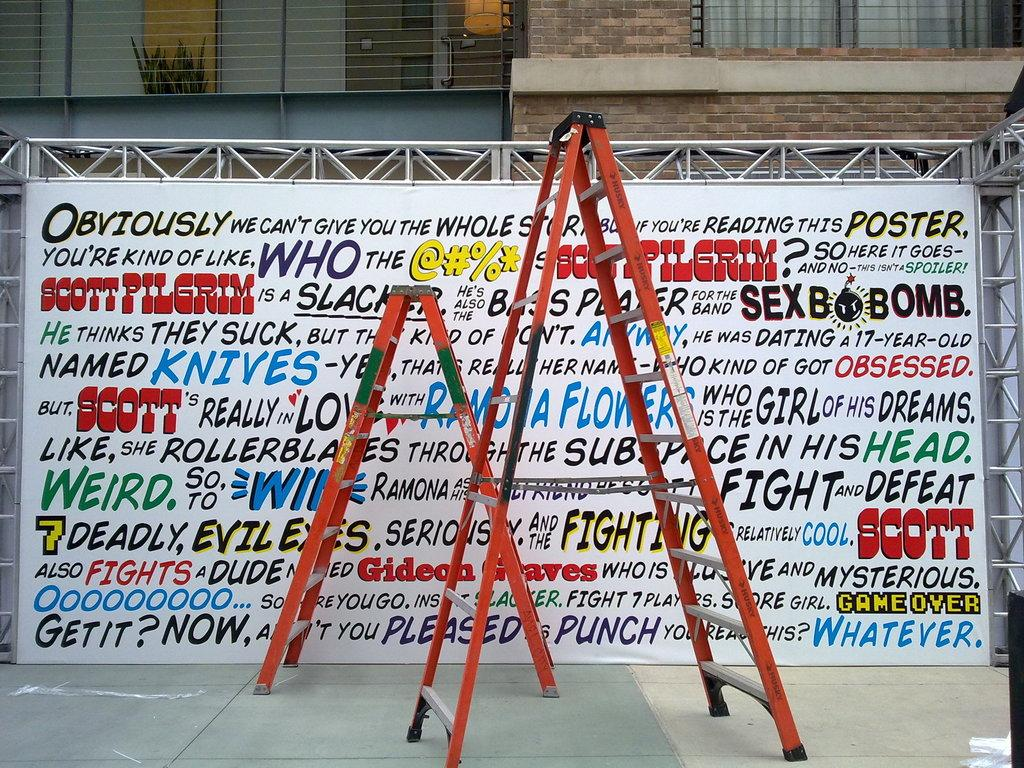<image>
Write a terse but informative summary of the picture. Two ladders are in front of a story about Scott Pilgrim written in different fonts. 